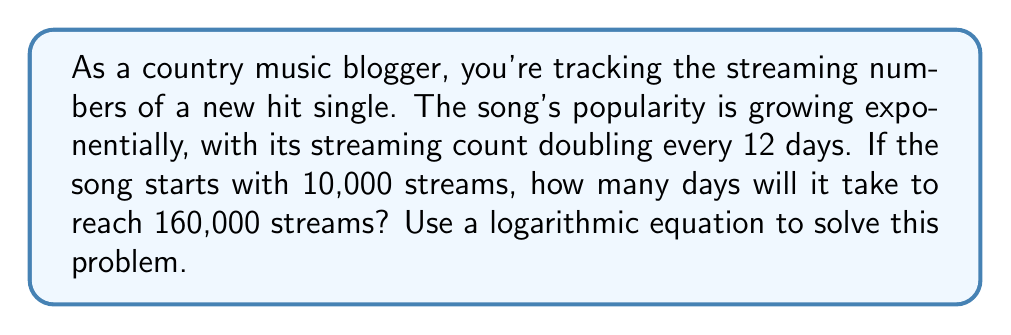Teach me how to tackle this problem. Let's approach this step-by-step using logarithms:

1) Let $y$ be the number of streams and $t$ be the time in days. We can express this relationship as:

   $y = 10000 \cdot 2^{\frac{t}{12}}$

2) We want to find $t$ when $y = 160000$. Let's substitute these values:

   $160000 = 10000 \cdot 2^{\frac{t}{12}}$

3) Divide both sides by 10000:

   $16 = 2^{\frac{t}{12}}$

4) Now, we can apply logarithms (base 2) to both sides:

   $\log_2(16) = \log_2(2^{\frac{t}{12}})$

5) The right side simplifies due to the logarithm rule $\log_a(a^x) = x$:

   $\log_2(16) = \frac{t}{12}$

6) We know that $\log_2(16) = 4$ because $2^4 = 16$. So:

   $4 = \frac{t}{12}$

7) Multiply both sides by 12:

   $48 = t$

Therefore, it will take 48 days for the song to reach 160,000 streams.
Answer: 48 days 